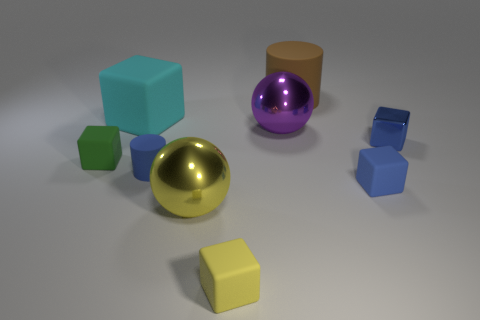Subtract all tiny yellow blocks. How many blocks are left? 4 Add 1 big cubes. How many objects exist? 10 Subtract all green cubes. How many cubes are left? 4 Subtract all gray spheres. How many blue cubes are left? 2 Subtract 2 balls. How many balls are left? 0 Add 5 brown matte cylinders. How many brown matte cylinders are left? 6 Add 2 large brown things. How many large brown things exist? 3 Subtract 0 cyan cylinders. How many objects are left? 9 Subtract all cubes. How many objects are left? 4 Subtract all gray cylinders. Subtract all brown cubes. How many cylinders are left? 2 